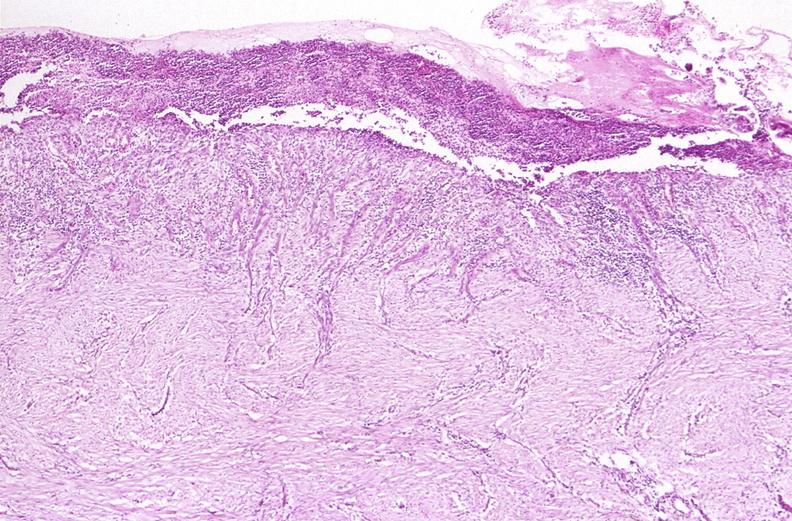s breast present?
Answer the question using a single word or phrase. No 